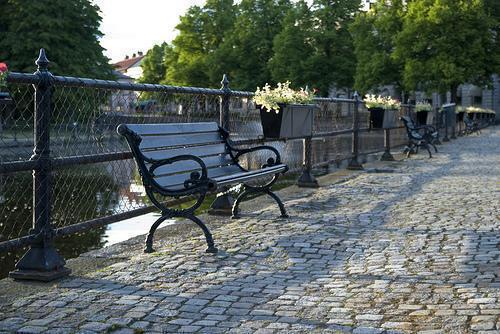What is the sidewalk made of?
Answer the question by selecting the correct answer among the 4 following choices.
Options: Cobblestones, concrete, slate, brick. Cobblestones. 